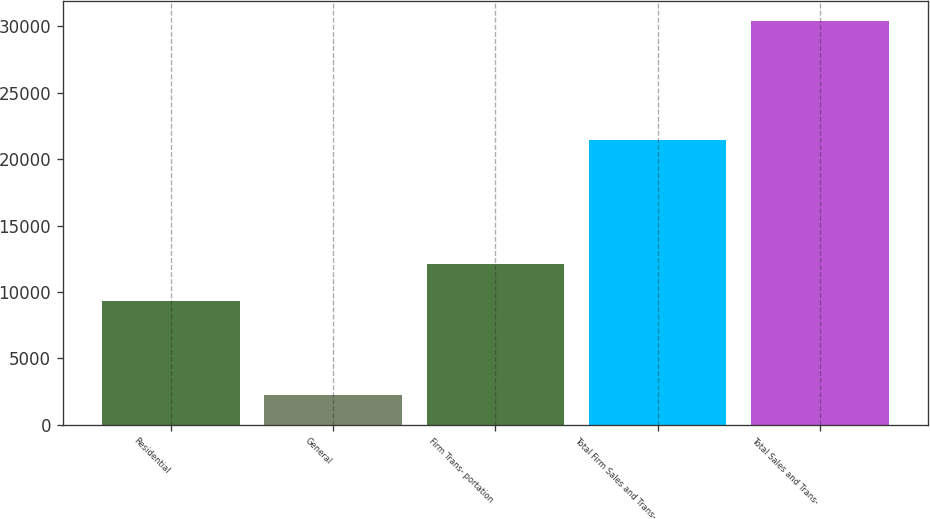Convert chart. <chart><loc_0><loc_0><loc_500><loc_500><bar_chart><fcel>Residential<fcel>General<fcel>Firm Trans- portation<fcel>Total Firm Sales and Trans-<fcel>Total Sales and Trans-<nl><fcel>9307<fcel>2269<fcel>12118.2<fcel>21417<fcel>30381<nl></chart> 